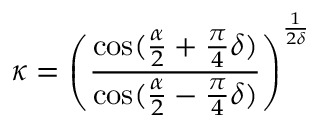Convert formula to latex. <formula><loc_0><loc_0><loc_500><loc_500>\kappa = \left ( \frac { \cos ( \frac { \alpha } { 2 } + \frac { \pi } { 4 } \delta ) } { \cos ( \frac { \alpha } { 2 } - \frac { \pi } { 4 } \delta ) } \right ) ^ { \frac { 1 } { 2 \delta } }</formula> 